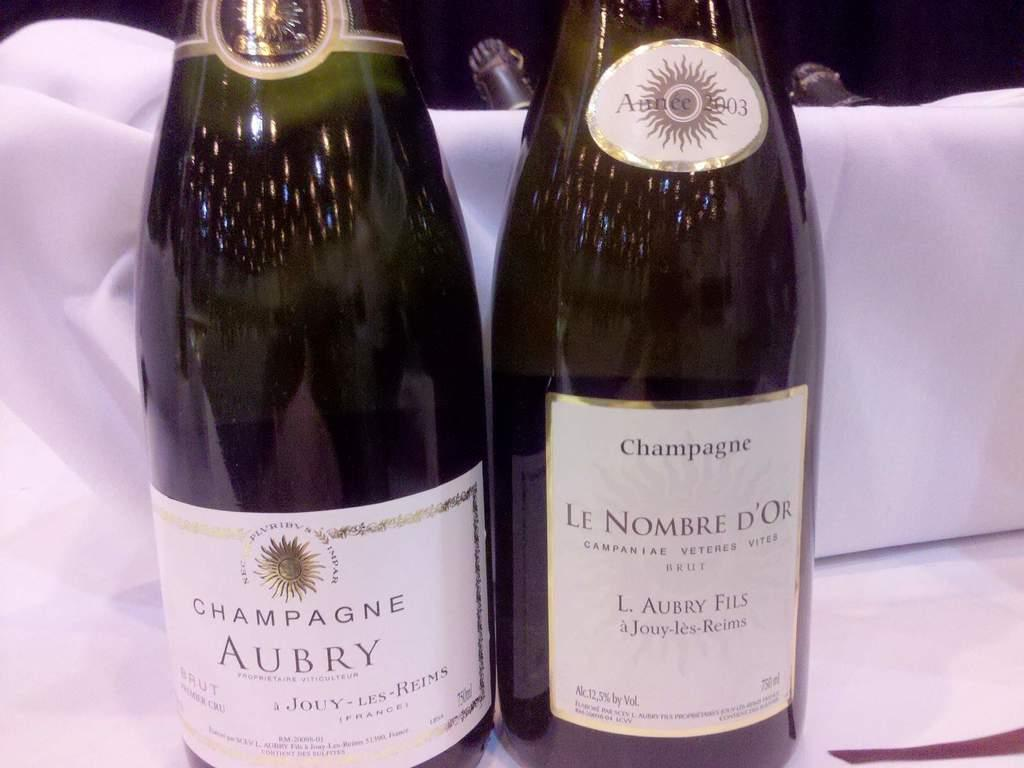<image>
Give a short and clear explanation of the subsequent image. the name Aubry that is on a bottle 